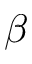Convert formula to latex. <formula><loc_0><loc_0><loc_500><loc_500>\beta</formula> 